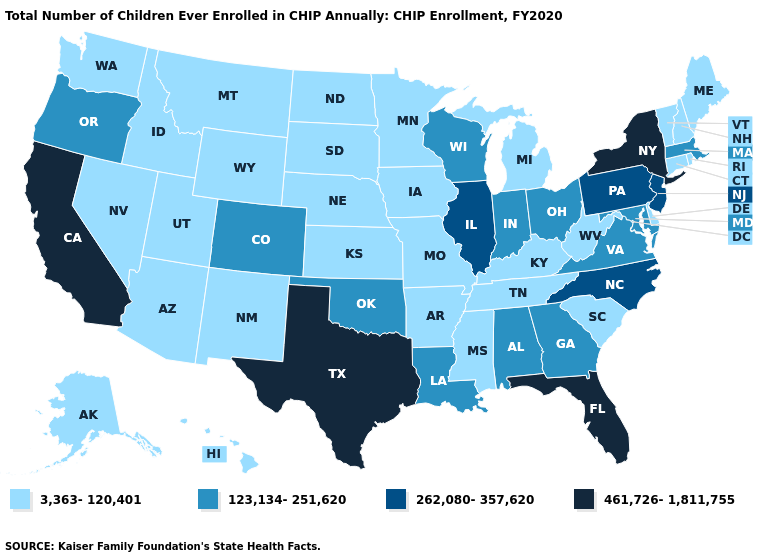What is the value of Mississippi?
Give a very brief answer. 3,363-120,401. What is the lowest value in states that border Indiana?
Short answer required. 3,363-120,401. Among the states that border Mississippi , does Tennessee have the highest value?
Answer briefly. No. Which states have the lowest value in the Northeast?
Keep it brief. Connecticut, Maine, New Hampshire, Rhode Island, Vermont. Among the states that border Delaware , does Maryland have the lowest value?
Concise answer only. Yes. Which states have the lowest value in the West?
Quick response, please. Alaska, Arizona, Hawaii, Idaho, Montana, Nevada, New Mexico, Utah, Washington, Wyoming. Does Colorado have the lowest value in the West?
Give a very brief answer. No. Among the states that border Kentucky , which have the highest value?
Quick response, please. Illinois. What is the highest value in the USA?
Concise answer only. 461,726-1,811,755. Does New York have the lowest value in the Northeast?
Be succinct. No. What is the value of Wyoming?
Give a very brief answer. 3,363-120,401. Which states have the highest value in the USA?
Write a very short answer. California, Florida, New York, Texas. Does the map have missing data?
Give a very brief answer. No. Name the states that have a value in the range 123,134-251,620?
Concise answer only. Alabama, Colorado, Georgia, Indiana, Louisiana, Maryland, Massachusetts, Ohio, Oklahoma, Oregon, Virginia, Wisconsin. Does Oklahoma have the lowest value in the South?
Give a very brief answer. No. 